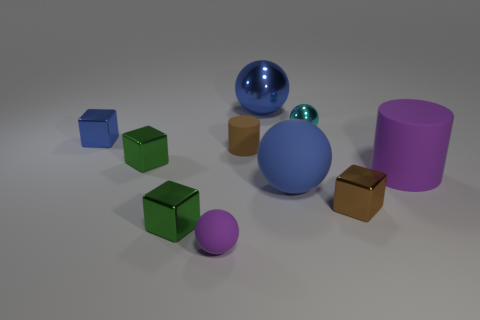What number of green metal objects are the same size as the brown metallic thing?
Provide a short and direct response. 2. Are the blue thing behind the small cyan ball and the tiny cyan sphere made of the same material?
Your response must be concise. Yes. Is the number of blue cubes in front of the small brown matte object less than the number of big gray cubes?
Your response must be concise. No. There is a purple matte thing in front of the blue rubber sphere; what shape is it?
Keep it short and to the point. Sphere. What is the shape of the purple object that is the same size as the cyan shiny ball?
Your answer should be very brief. Sphere. Is there another metal object that has the same shape as the tiny cyan thing?
Give a very brief answer. Yes. There is a small brown object on the left side of the cyan shiny object; is its shape the same as the purple thing to the left of the small matte cylinder?
Your answer should be very brief. No. What material is the cylinder that is the same size as the blue shiny block?
Your answer should be very brief. Rubber. What number of other things are there of the same material as the small purple thing
Your answer should be very brief. 3. The purple object that is right of the purple object that is in front of the brown cube is what shape?
Your answer should be compact. Cylinder. 